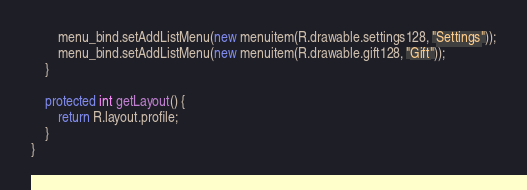Convert code to text. <code><loc_0><loc_0><loc_500><loc_500><_Java_>        menu_bind.setAddListMenu(new menuitem(R.drawable.settings128, "Settings"));
        menu_bind.setAddListMenu(new menuitem(R.drawable.gift128, "Gift"));
    }

    protected int getLayout() {
        return R.layout.profile;
    }
}
</code> 